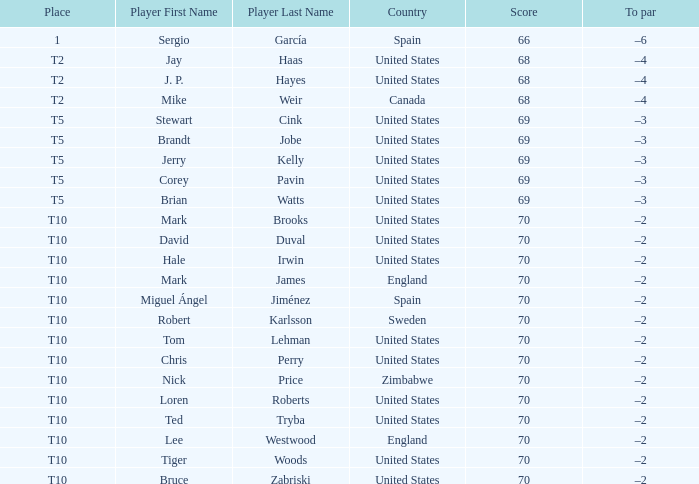What was the To par of the golfer that placed t5? –3, –3, –3, –3, –3. 